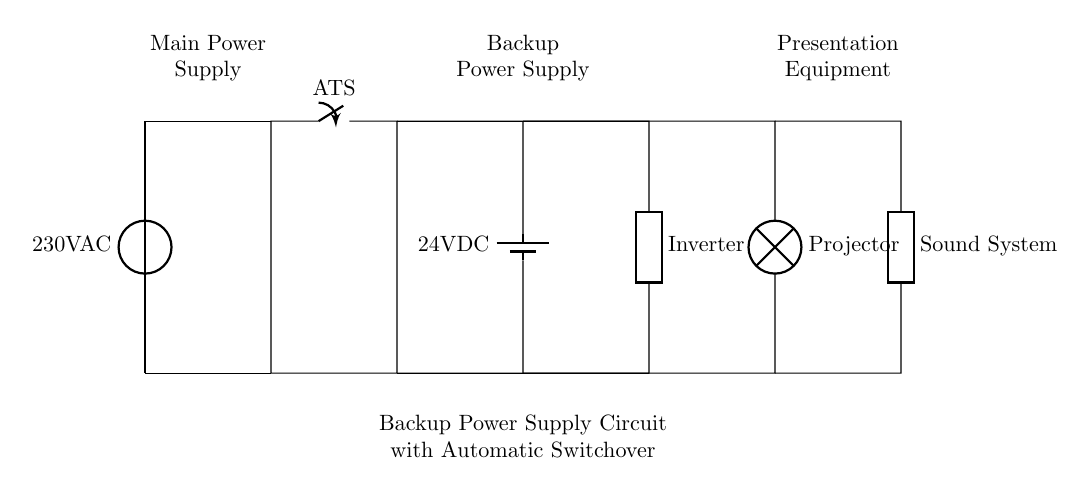what type of switch is used in this circuit? The switch used in the circuit is labeled as ATS, which stands for Automatic Transfer Switch. This type of switch is designed to automatically switch the power supply from the main source to a backup source when there is an outage.
Answer: Automatic Transfer Switch what is the voltage of the backup battery? The backup battery is labeled as 24V DC, indicating that it provides a direct current voltage of 24 volts.
Answer: 24V DC how many loads are connected to the output of the automatic transfer switch? There are two loads connected to the output: a projector and a sound system. Each is represented in the circuit diagram as a separate component.
Answer: Two what happens when the main power supply fails? When the main power supply fails, the Automatic Transfer Switch detects the outage and automatically switches the power source to the backup battery and inverter, ensuring that the presentation equipment continues to function without interruption.
Answer: Switchover to backup battery what is the purpose of the inverter in this circuit? The inverter's purpose is to convert the backup battery's direct current (24V DC) into alternating current (AC), which is necessary for powering the presentation equipment that typically operates on 230V AC.
Answer: Convert DC to AC which components are part of the presentation equipment? The components part of the presentation equipment include a projector and a sound system, as indicated in the circuit diagram.
Answer: Projector and Sound System 